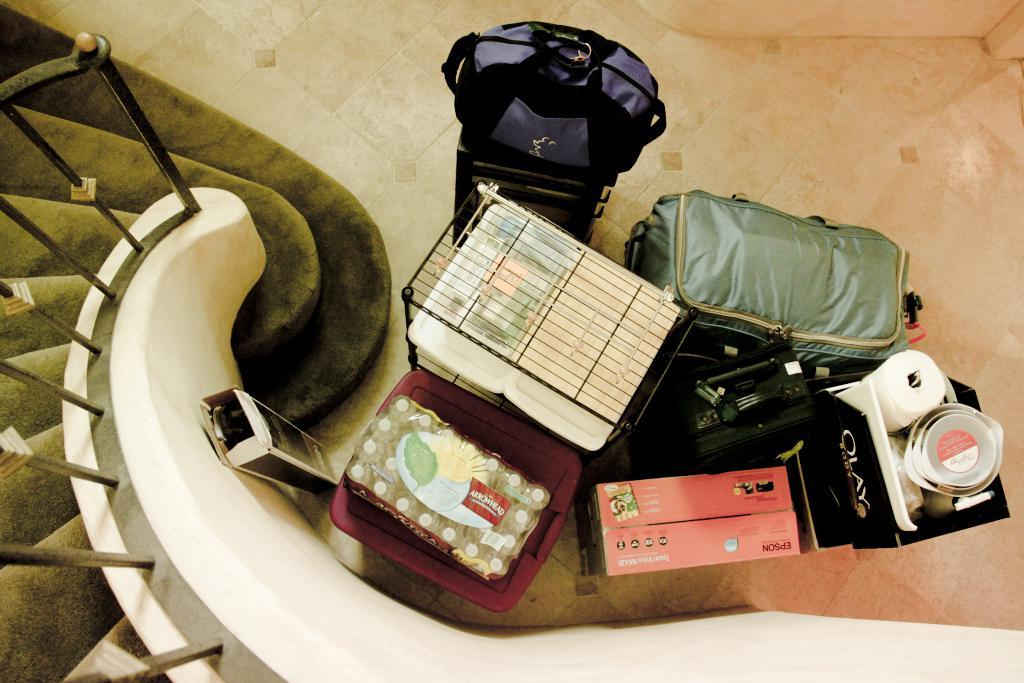What type of luggage is visible in the image? There is luggage with boxes in the image. What other type of luggage can be seen in the image? There is a suitcase in the image. What is the purpose of the net in the image? The purpose of the net is not clear from the image, but it might be used for holding or organizing items. What type of bags are present in the image? There are bags in the image, but their specific type is not mentioned. What is the purpose of the tissue paper in the image? The tissue paper might be used for wrapping or protecting items. What type of containers are present in the image? There are bowls in the image, which are part of a bottle package. What architectural feature is visible in the image? There are steps in the image, and a fence is associated with the steps. How many pizzas are visible in the image? There are no pizzas present in the image. What type of cow can be seen grazing near the steps in the image? There is no cow present in the image. What type of prose is written on the tissue paper in the image? There is no writing or prose visible on the tissue paper in the image. 